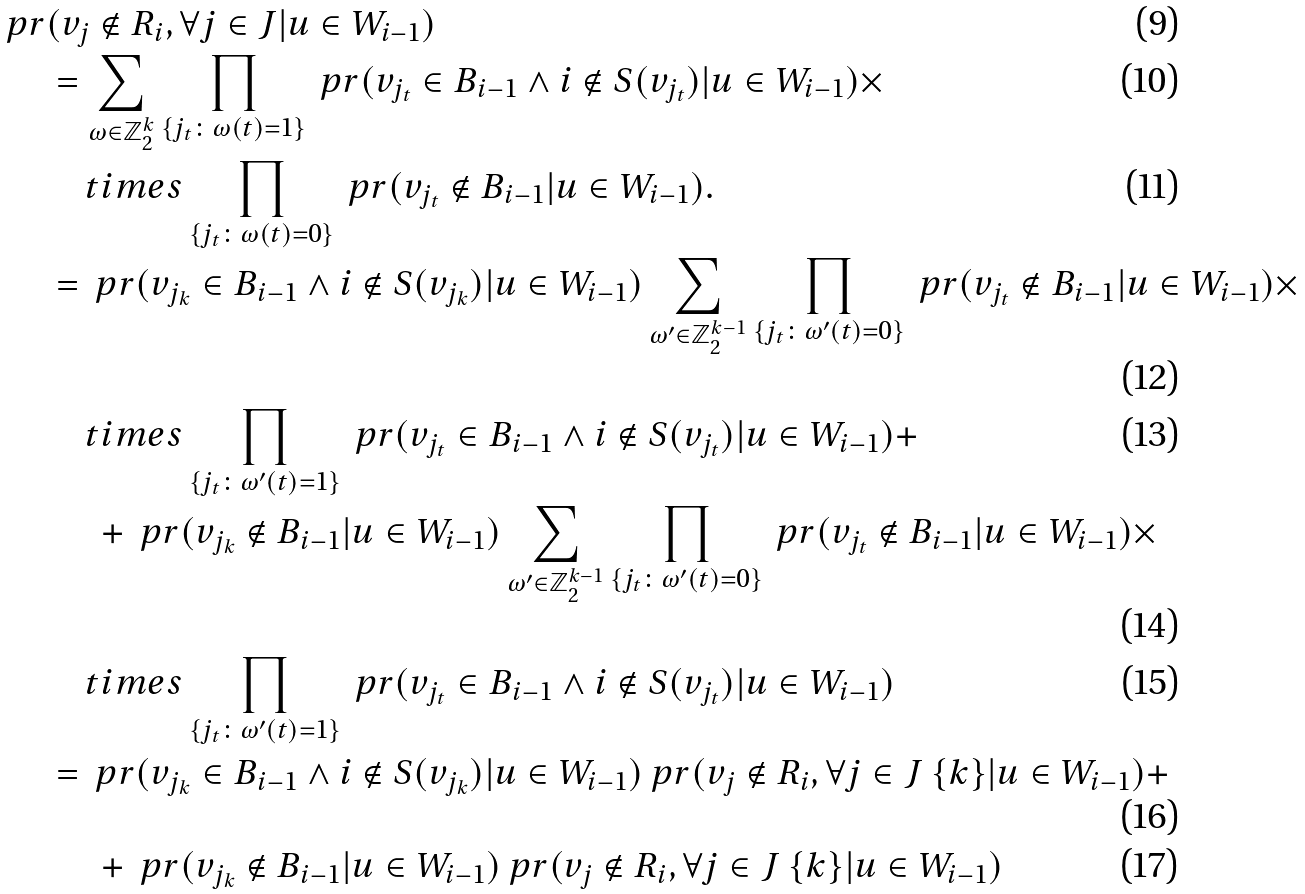Convert formula to latex. <formula><loc_0><loc_0><loc_500><loc_500>\ p r & ( v _ { j } \notin R _ { i } , \forall j \in J | u \in W _ { i - 1 } ) \\ & = \sum _ { \omega \in \mathbb { Z } _ { 2 } ^ { k } } \prod _ { \{ j _ { t } \colon \omega ( t ) = 1 \} } \ p r ( v _ { j _ { t } } \in B _ { i - 1 } \wedge i \notin S ( v _ { j _ { t } } ) | u \in W _ { i - 1 } ) \times \\ & \quad t i m e s \prod _ { \{ j _ { t } \colon \omega ( t ) = 0 \} } \ p r ( v _ { j _ { t } } \notin B _ { i - 1 } | u \in W _ { i - 1 } ) . \\ & = \ p r ( v _ { j _ { k } } \in B _ { i - 1 } \wedge i \notin S ( v _ { j _ { k } } ) | u \in W _ { i - 1 } ) \sum _ { \omega ^ { \prime } \in \mathbb { Z } _ { 2 } ^ { k - 1 } } \prod _ { \{ j _ { t } \colon \omega ^ { \prime } ( t ) = 0 \} } \ p r ( v _ { j _ { t } } \notin B _ { i - 1 } | u \in W _ { i - 1 } ) \times \\ & \quad t i m e s \prod _ { \{ j _ { t } \colon \omega ^ { \prime } ( t ) = 1 \} } \ p r ( v _ { j _ { t } } \in B _ { i - 1 } \wedge i \notin S ( v _ { j _ { t } } ) | u \in W _ { i - 1 } ) + \\ & \quad \ + \ p r ( v _ { j _ { k } } \notin B _ { i - 1 } | u \in W _ { i - 1 } ) \sum _ { \omega ^ { \prime } \in \mathbb { Z } _ { 2 } ^ { k - 1 } } \prod _ { \{ j _ { t } \colon \omega ^ { \prime } ( t ) = 0 \} } \ p r ( v _ { j _ { t } } \notin B _ { i - 1 } | u \in W _ { i - 1 } ) \times \\ & \quad t i m e s \prod _ { \{ j _ { t } \colon \omega ^ { \prime } ( t ) = 1 \} } \ p r ( v _ { j _ { t } } \in B _ { i - 1 } \wedge i \notin S ( v _ { j _ { t } } ) | u \in W _ { i - 1 } ) \\ & = \ p r ( v _ { j _ { k } } \in B _ { i - 1 } \wedge i \notin S ( v _ { j _ { k } } ) | u \in W _ { i - 1 } ) \ p r ( v _ { j } \notin R _ { i } , \forall j \in J \ \{ k \} | u \in W _ { i - 1 } ) + \\ & \quad \ + \ p r ( v _ { j _ { k } } \notin B _ { i - 1 } | u \in W _ { i - 1 } ) \ p r ( v _ { j } \notin R _ { i } , \forall j \in J \ \{ k \} | u \in W _ { i - 1 } )</formula> 